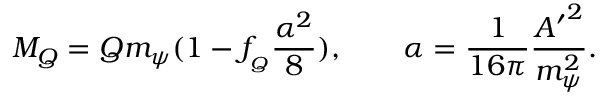Convert formula to latex. <formula><loc_0><loc_0><loc_500><loc_500>M _ { Q } = Q m _ { \psi } ( 1 - f _ { _ { Q } } \frac { \alpha ^ { 2 } } { 8 } ) , \quad \alpha = \frac { 1 } { 1 6 \pi } \frac { { A ^ { \prime } } ^ { 2 } } { m _ { \psi } ^ { 2 } } .</formula> 